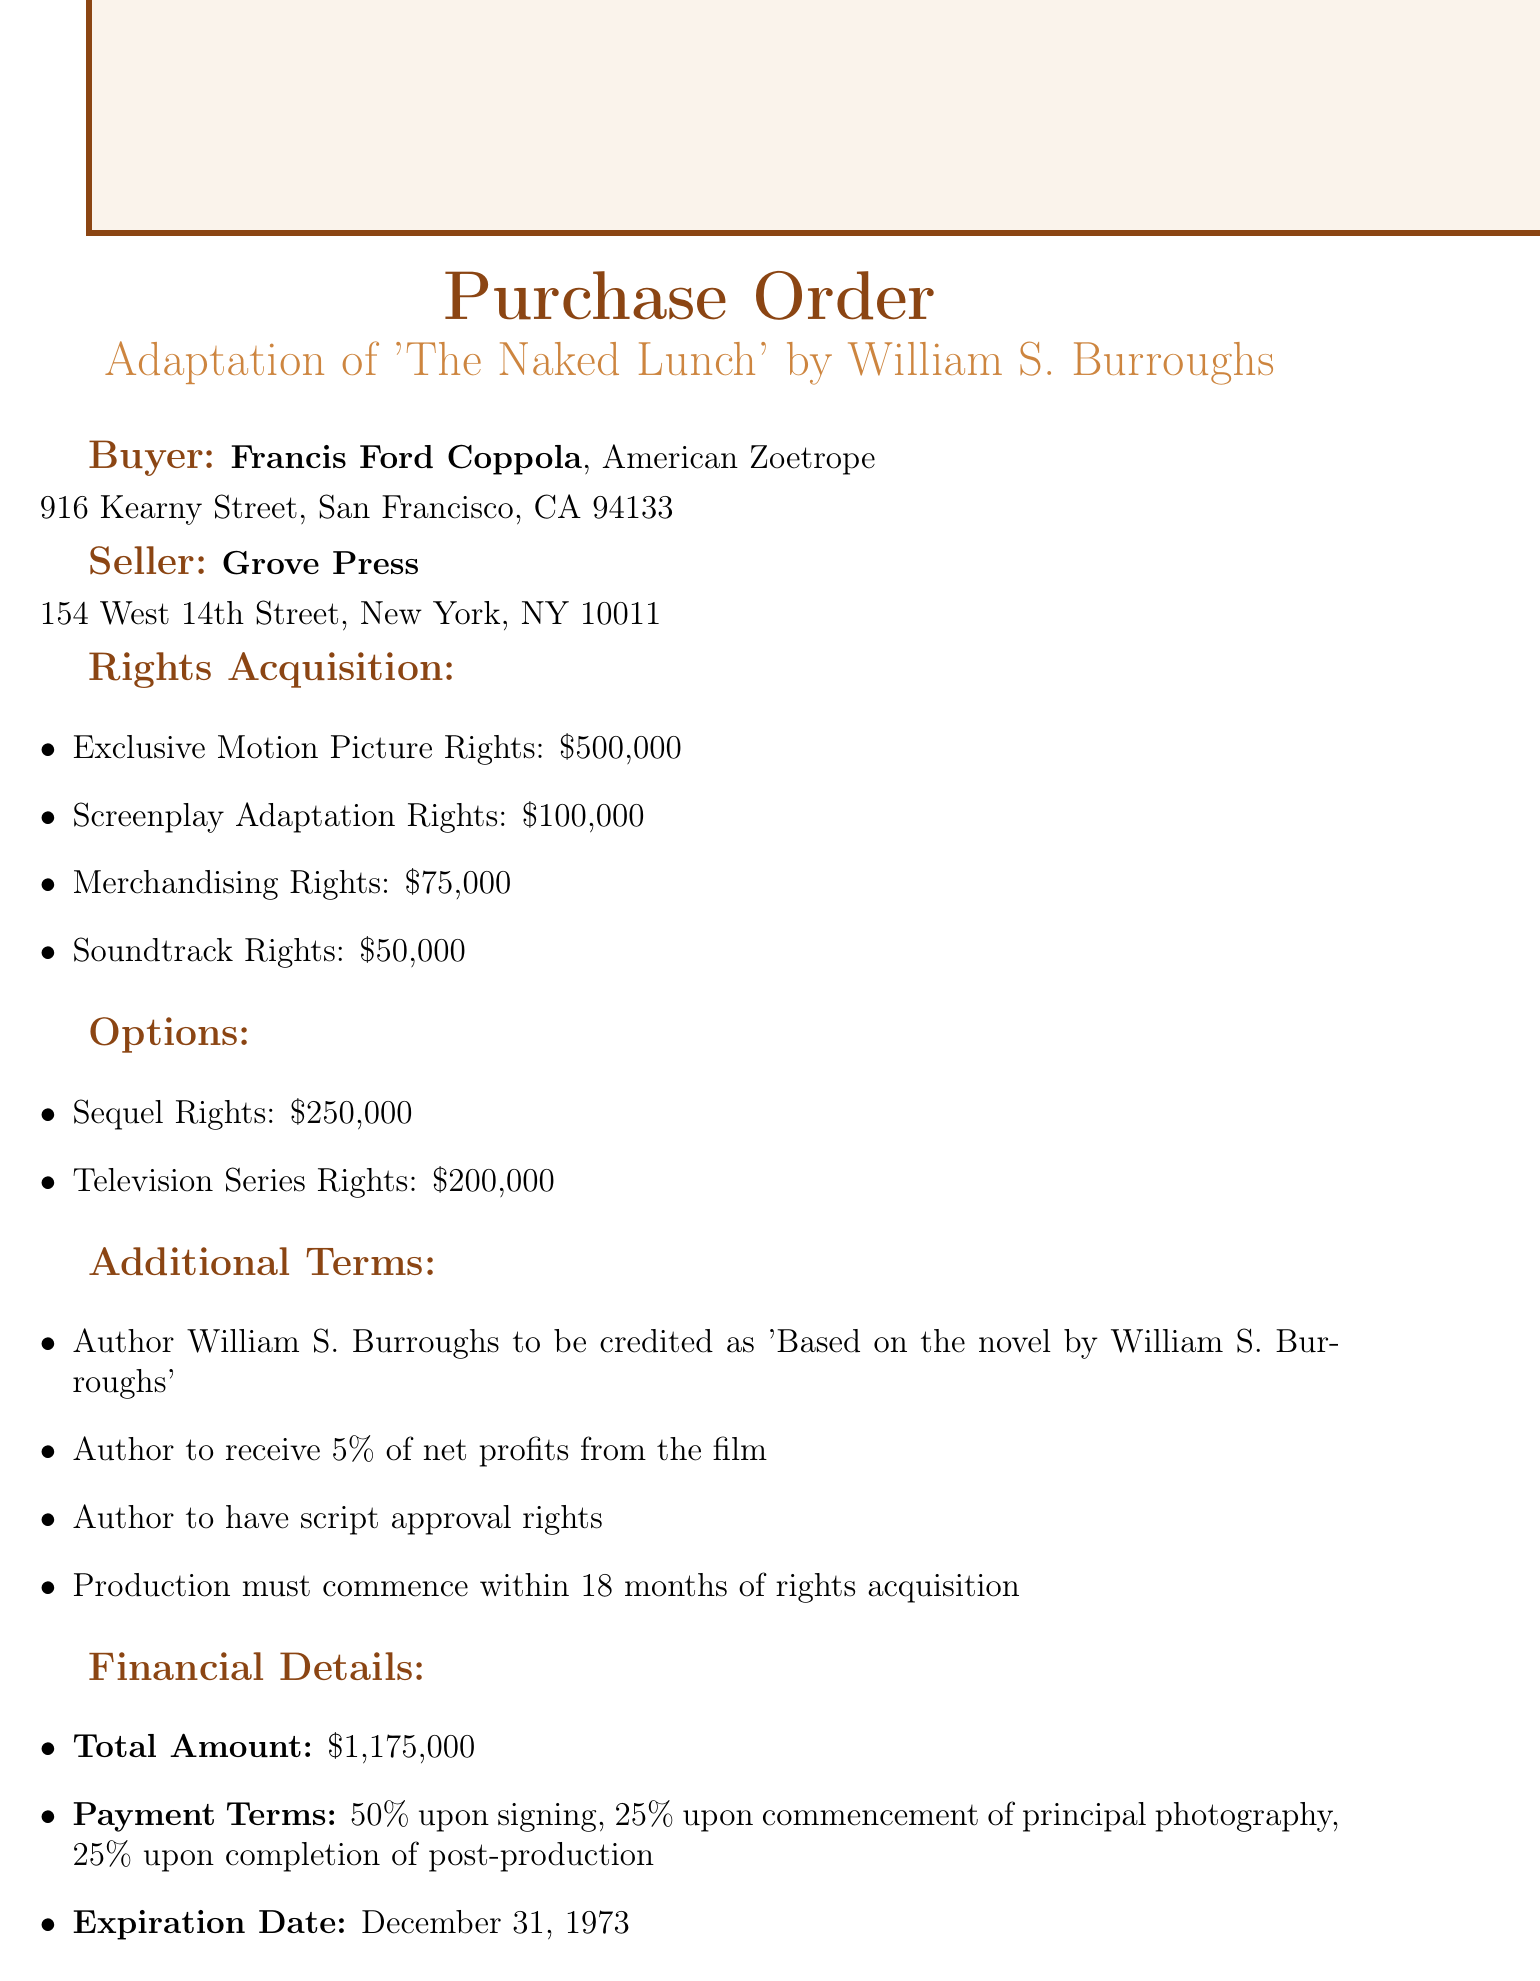what is the buyer's name? The buyer's name is listed at the top of the document under the Buyer section.
Answer: Francis Ford Coppola what is the total amount? The total amount is stated in the Financial Details section of the document.
Answer: $1,175,000 who is the seller? The seller's name is provided in the Seller section of the document.
Answer: Grove Press what are the payment terms? The payment terms are specified under the Financial Details section.
Answer: 50% upon signing, 25% upon commencement of principal photography, 25% upon completion of post-production what rights are being acquired? The rights acquired are detailed in the Rights Acquisition section, listing each item with its fee.
Answer: Exclusive Motion Picture Rights, Screenplay Adaptation Rights, Merchandising Rights, Soundtrack Rights what is the expiration date of the purchase order? The expiration date is specified in the Financial Details section.
Answer: December 31, 1973 how much is the fee for Sequel Rights? The fee for Sequel Rights is found in the Options section of the document.
Answer: $250,000 who must be credited in the film? The additional terms state who should be credited in the film adaptation.
Answer: William S. Burroughs how much does the author receive from net profits? The author’s profit share percentage is mentioned in the Additional Terms.
Answer: 5% 